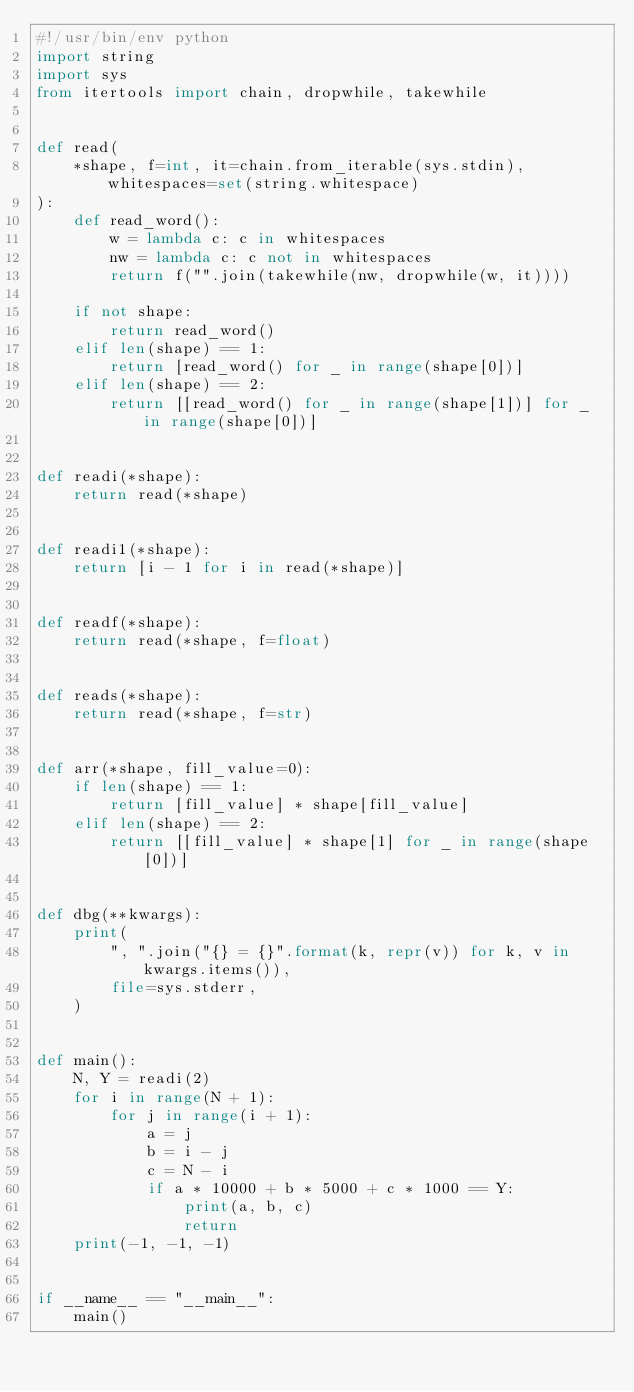<code> <loc_0><loc_0><loc_500><loc_500><_Python_>#!/usr/bin/env python
import string
import sys
from itertools import chain, dropwhile, takewhile


def read(
    *shape, f=int, it=chain.from_iterable(sys.stdin), whitespaces=set(string.whitespace)
):
    def read_word():
        w = lambda c: c in whitespaces
        nw = lambda c: c not in whitespaces
        return f("".join(takewhile(nw, dropwhile(w, it))))

    if not shape:
        return read_word()
    elif len(shape) == 1:
        return [read_word() for _ in range(shape[0])]
    elif len(shape) == 2:
        return [[read_word() for _ in range(shape[1])] for _ in range(shape[0])]


def readi(*shape):
    return read(*shape)


def readi1(*shape):
    return [i - 1 for i in read(*shape)]


def readf(*shape):
    return read(*shape, f=float)


def reads(*shape):
    return read(*shape, f=str)


def arr(*shape, fill_value=0):
    if len(shape) == 1:
        return [fill_value] * shape[fill_value]
    elif len(shape) == 2:
        return [[fill_value] * shape[1] for _ in range(shape[0])]


def dbg(**kwargs):
    print(
        ", ".join("{} = {}".format(k, repr(v)) for k, v in kwargs.items()),
        file=sys.stderr,
    )


def main():
    N, Y = readi(2)
    for i in range(N + 1):
        for j in range(i + 1):
            a = j
            b = i - j
            c = N - i
            if a * 10000 + b * 5000 + c * 1000 == Y:
                print(a, b, c)
                return
    print(-1, -1, -1)


if __name__ == "__main__":
    main()
</code> 